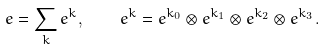<formula> <loc_0><loc_0><loc_500><loc_500>e = \sum _ { k } e ^ { k } , \quad e ^ { k } = e ^ { k _ { 0 } } \otimes e ^ { k _ { 1 } } \otimes e ^ { k _ { 2 } } \otimes e ^ { k _ { 3 } } .</formula> 